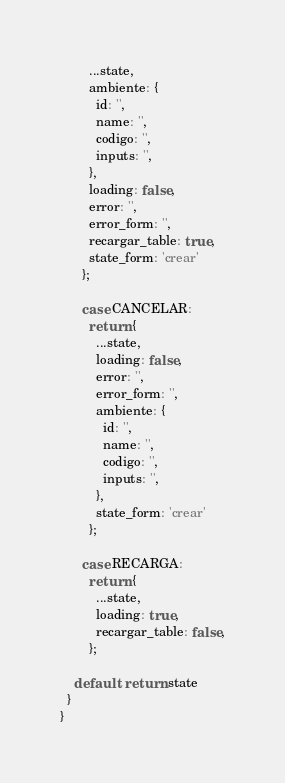Convert code to text. <code><loc_0><loc_0><loc_500><loc_500><_JavaScript_>        ...state,
        ambiente: {
          id: '',
          name: '',
          codigo: '',
          inputs: '',
        },
        loading: false,
        error: '',
        error_form: '',
        recargar_table: true,
        state_form: 'crear'
      };

      case CANCELAR:
        return {
          ...state,
          loading: false,
          error: '',
          error_form: '',
          ambiente: {
            id: '',
            name: '',
            codigo: '',
            inputs: '',
          },
          state_form: 'crear'
        };
  
      case RECARGA:
        return {
          ...state,
          loading: true,
          recargar_table: false,
        };

    default: return state
  }
}</code> 